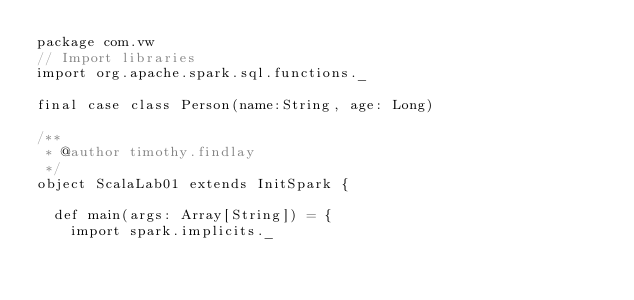<code> <loc_0><loc_0><loc_500><loc_500><_Scala_>package com.vw
// Import libraries
import org.apache.spark.sql.functions._

final case class Person(name:String, age: Long)

/**
 * @author timothy.findlay
 */
object ScalaLab01 extends InitSpark {

  def main(args: Array[String]) = {
    import spark.implicits._</code> 